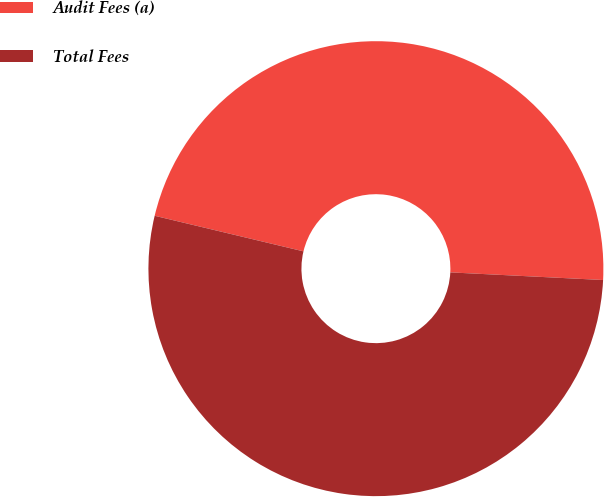Convert chart. <chart><loc_0><loc_0><loc_500><loc_500><pie_chart><fcel>Audit Fees (a)<fcel>Total Fees<nl><fcel>47.06%<fcel>52.94%<nl></chart> 